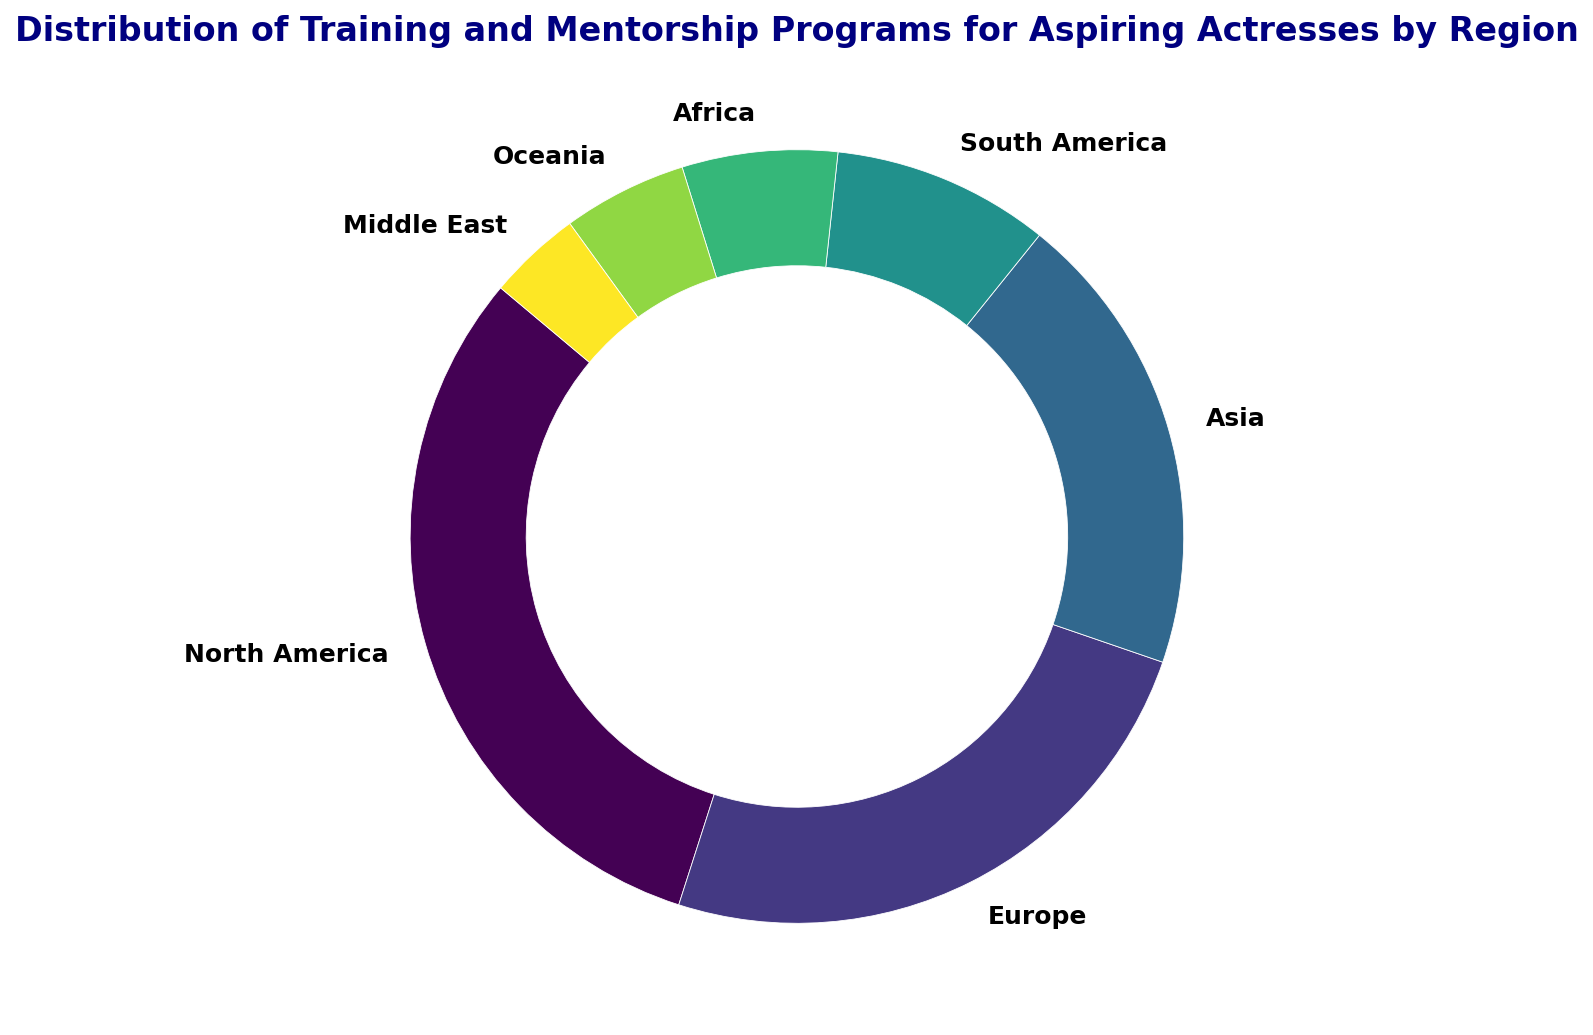What's the region with the highest number of programs? The pie chart shows the distribution of programs by region, and North America has the largest slice, indicating it has the highest number of programs.
Answer: North America Which region has the smallest percentage of programs? By observing the pie chart, the Middle East has the smallest slice, indicating the smallest percentage of programs.
Answer: Middle East What percentage of programs are in Europe and Asia combined? Europe has 95 programs and Asia has 75. The total number of programs is 385. The combined percentage is (95 + 75) / 385 * 100, which equals 44.2%.
Answer: 44.2% How does the number of programs in South America compare to that in Africa? South America has 35 programs, and Africa has 25. By comparing those, South America has 10 more programs than Africa.
Answer: 10 more Which regions have less than 10% of the total programs? First, calculate 10% of the total programs (385), which is 38.5. South America, Africa, Oceania, and Middle East have fewer than 38.5 programs each, hence less than 10%.
Answer: South America, Africa, Oceania, Middle East What is the difference in the number of programs between North America and Europe? North America has 120 programs, and Europe has 95. The difference is 120 - 95 = 25 programs.
Answer: 25 What percentage of programs are in the Oceania region? Oceania has 20 programs. The total number of programs is 385. The percentage is (20 / 385) * 100, which equals approximately 5.2%.
Answer: 5.2% If the total number of programs increased by 50, and all were added to Africa, what percentage of the total programs would Africa have then? Current total is 385. Adding 50 makes it 435. Africa would then have 25 + 50 = 75 programs. The percentage is (75 / 435) * 100, which equals approximately 17.2%.
Answer: 17.2% How many regions have more programs than Oceania? Oceania has 20 programs. North America (120), Europe (95), Asia (75), South America (35), and Africa (25) all have more programs than Oceania, making it 5 regions.
Answer: 5 